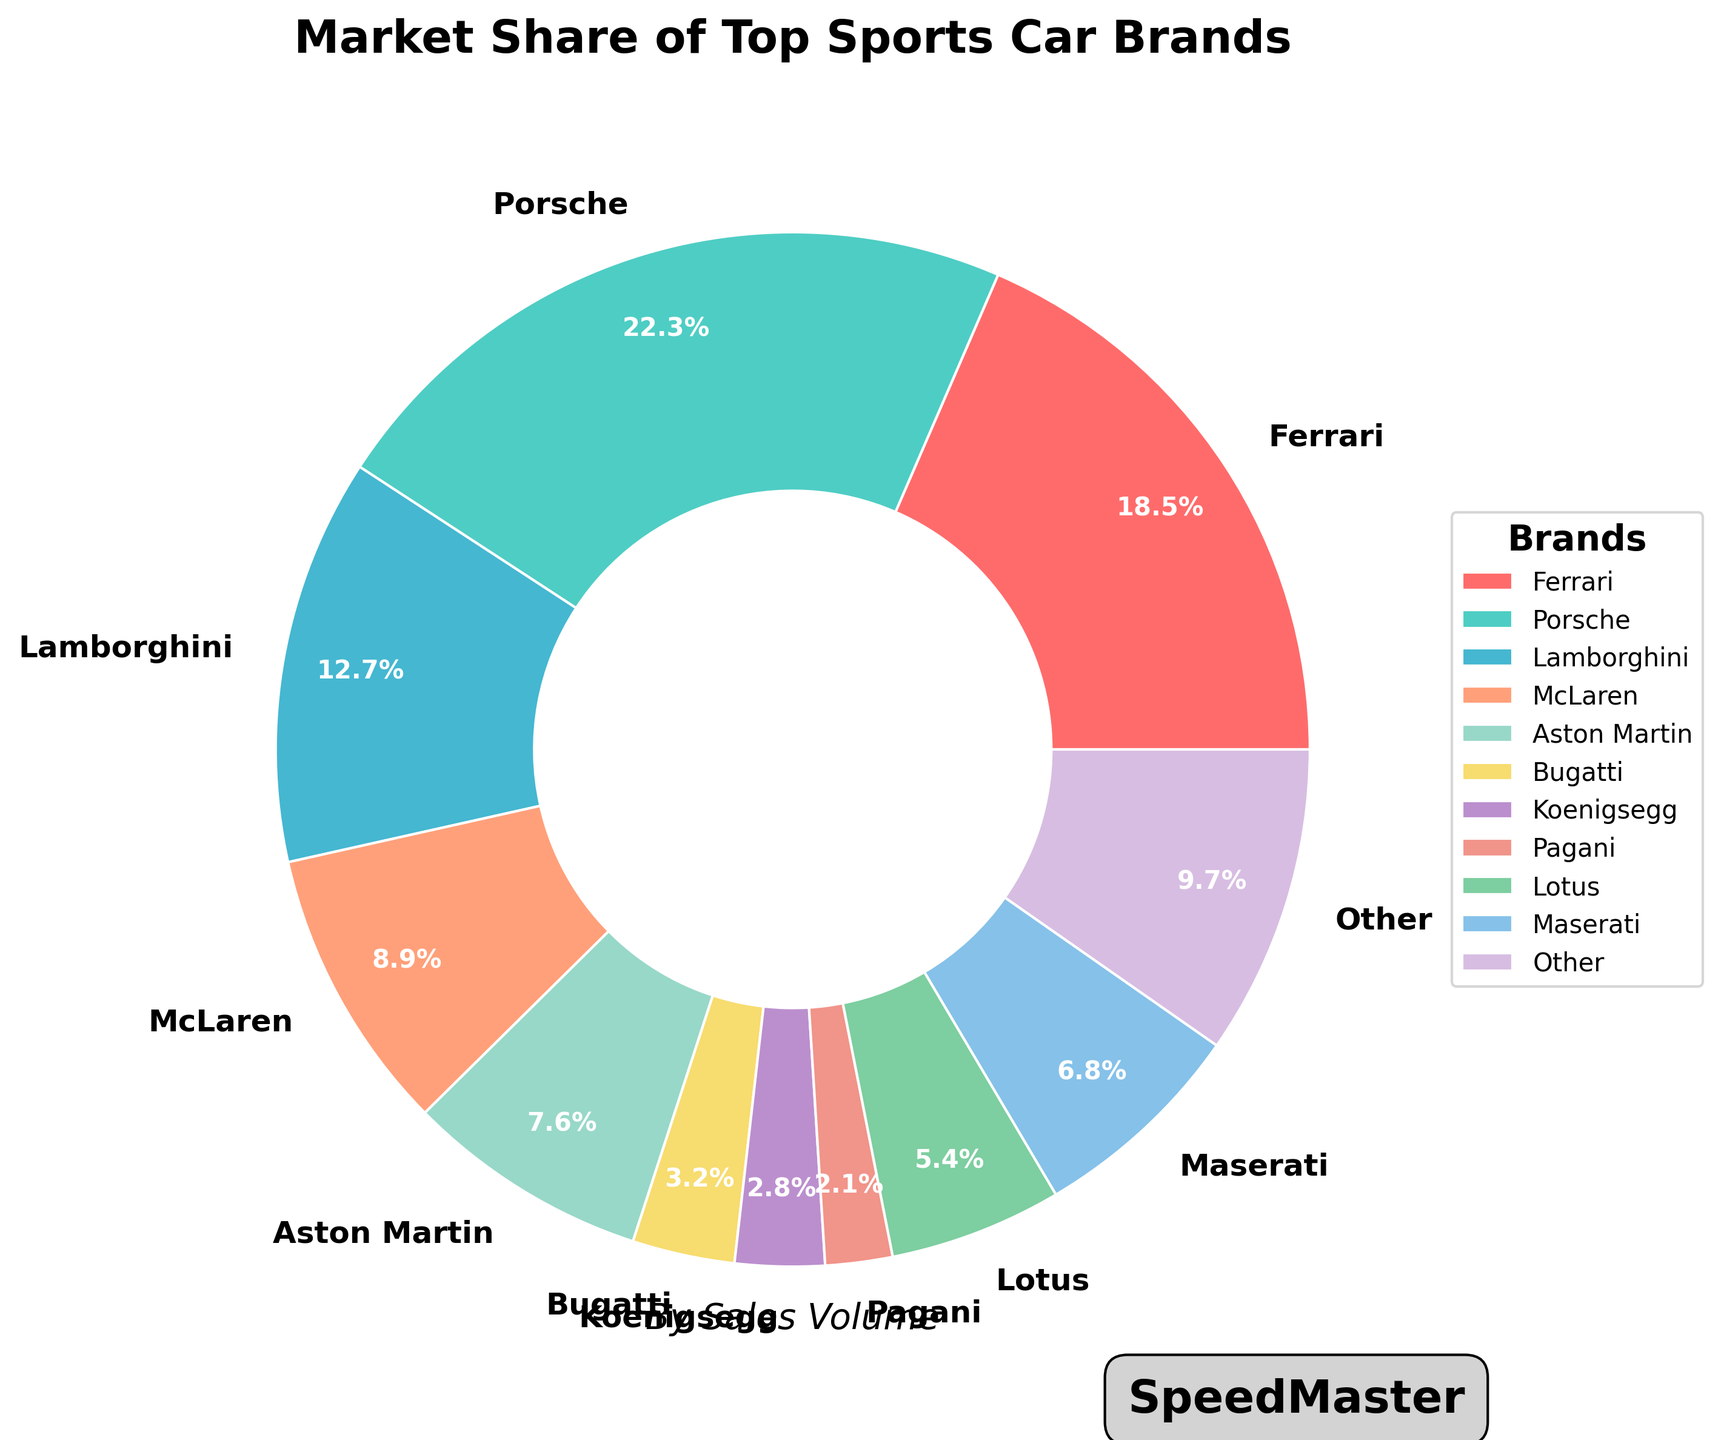What are the two brands with the highest market share? The brands with the highest market shares are those with the largest percentage values in the pie chart. By inspecting the chart, Porsche has 22.3% and Ferrari has 18.5%.
Answer: Porsche and Ferrari Which brand has the lowest market share and what is it? The lowest market share is represented by the smallest percentage in the pie chart. Pagani has the smallest wedge, which is 2.1%.
Answer: Pagani, 2.1% How much more market share does Porsche have compared to Bugatti? Porsche's market share is 22.3% and Bugatti's is 3.2%. Subtract Bugatti's share from Porsche's: 22.3% - 3.2% = 19.1%.
Answer: 19.1% What is the combined market share of McLaren and Aston Martin? McLaren has 8.9% and Aston Martin has 7.6%. Adding these together gives 8.9% + 7.6% = 16.5%.
Answer: 16.5% Which brands have a market share of less than 5%? By looking at the chart, four brands have market shares below 5%: Bugatti (3.2%), Koenigsegg (2.8%), Pagani (2.1%), and Lotus (5.4%). Note: Lotus is slightly above 5%. To fit the criteria, we exclude Lotus.
Answer: Bugatti, Koenigsegg, Pagani Which brand’s market share is closest to 10%? By looking at the chart, we see that Lamborghini has a market share of 12.7%, which is the closest to 10%.
Answer: Lamborghini What is the average market share of Ferrari, Lamborghini, and McLaren? Ferrari's market share is 18.5%, Lamborghini's is 12.7%, and McLaren's is 8.9%. The average market share is calculated by (18.5% + 12.7% + 8.9%) / 3 = 13.37%.
Answer: 13.37% Compare the combined market share of Koenigsegg and Pagani to Lotus. Which is greater? Koenigsegg has 2.8% and Pagani has 2.1%, combined they have 2.8% + 2.1% = 4.9%. Lotus has 5.4%. Comparing 4.9% to 5.4%, Lotus's market share is greater.
Answer: Lotus If the market share of Aston Martin doubled, what would be the total market share of Aston Martin and Porsche? Aston Martin's current market share is 7.6%. Doubling it would be 7.6% x 2 = 15.2%. Adding this to Porsche's share: 15.2% + 22.3% = 37.5%.
Answer: 37.5% How does the market share of Ferrari compare to the total market share of brands with less than 5%? Brands with less than 5% are Bugatti (3.2%), Koenigsegg (2.8%), Pagani (2.1%). Their total market share is 3.2% + 2.8% + 2.1% = 8.1%. Ferrari's market share is 18.5%, which is greater than the combined 8.1%.
Answer: Greater 